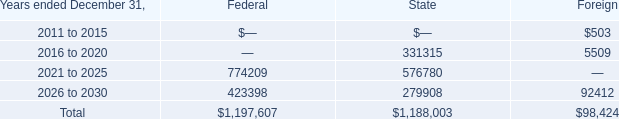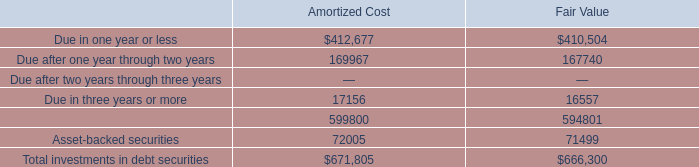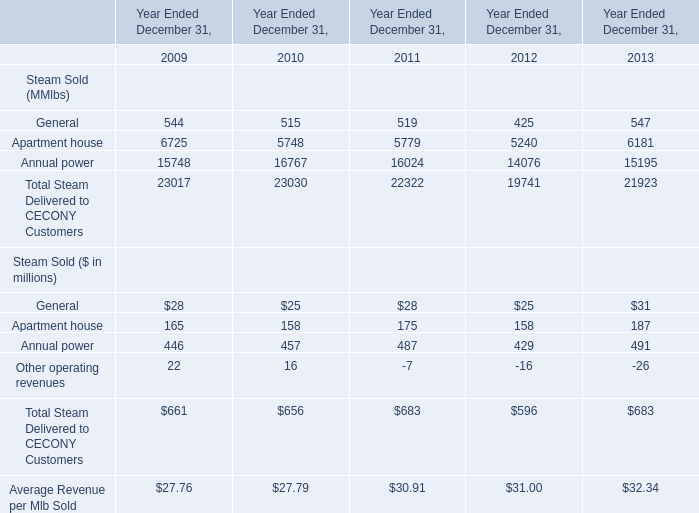What's the sum of 2016 to 2020 of Foreign, and Apartment house of Year Ended December 31, 2011 ? 
Computations: (5509.0 + 5779.0)
Answer: 11288.0. 